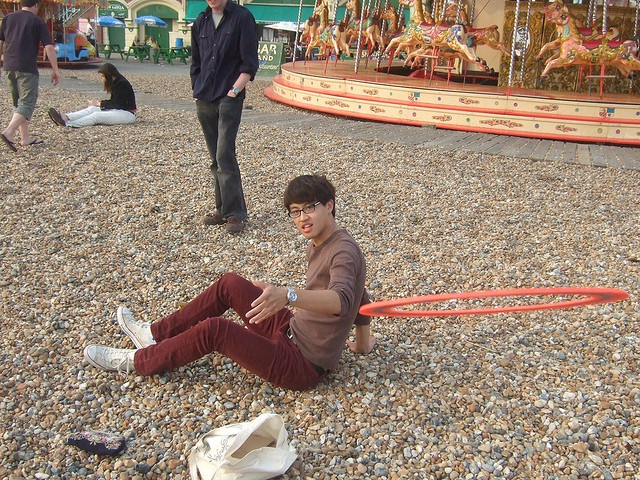Describe the objects in this image and their specific colors. I can see people in gray, maroon, brown, and black tones, people in gray, black, and darkgray tones, handbag in gray, lightgray, and darkgray tones, frisbee in gray, salmon, and brown tones, and people in gray and black tones in this image. 